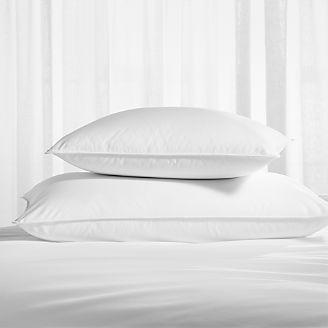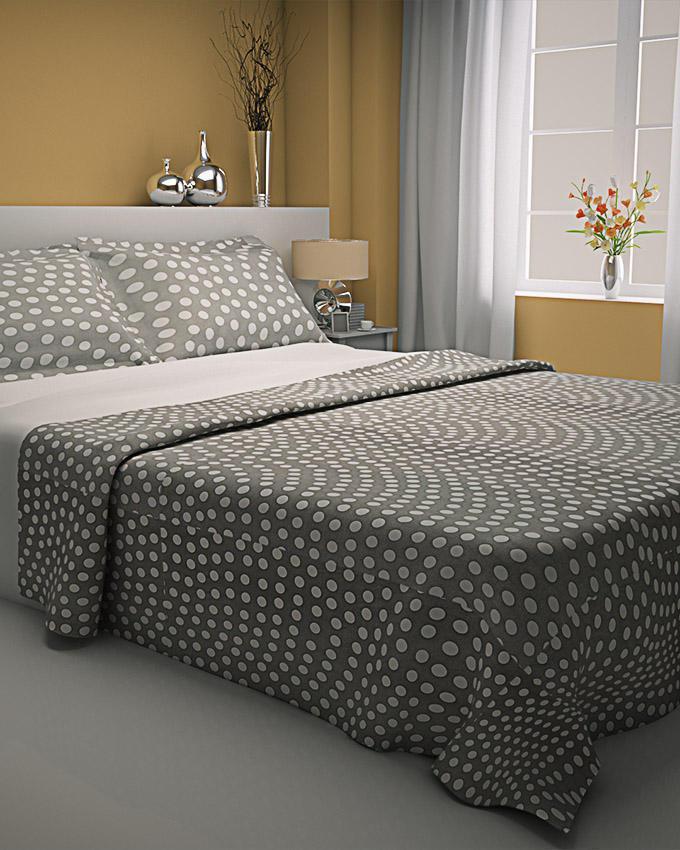The first image is the image on the left, the second image is the image on the right. For the images shown, is this caption "The left and right images both show white pillows on a bed with all white bedding." true? Answer yes or no. No. The first image is the image on the left, the second image is the image on the right. Assess this claim about the two images: "Each image shows a bed with white bedding and white pillows, and one image shows a long narrow pillow in front of at least four taller rectangular pillows.". Correct or not? Answer yes or no. No. 